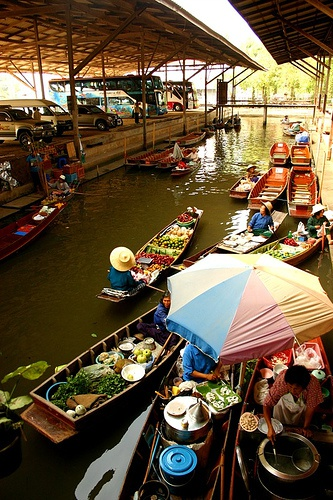Describe the objects in this image and their specific colors. I can see umbrella in black, beige, lightblue, tan, and lightpink tones, boat in black, ivory, maroon, and olive tones, boat in black, maroon, olive, and tan tones, boat in black, khaki, maroon, and beige tones, and people in black, maroon, and brown tones in this image. 